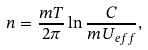<formula> <loc_0><loc_0><loc_500><loc_500>n = \frac { m T } { 2 \pi } \ln \frac { C } { m U _ { e f f } } ,</formula> 